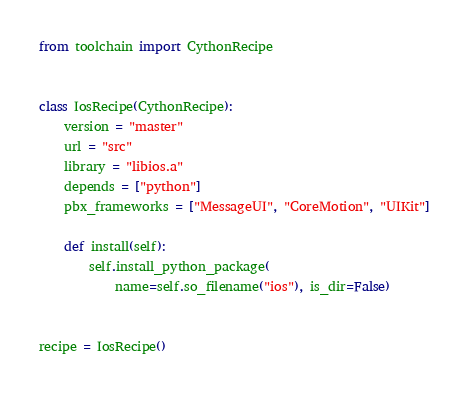<code> <loc_0><loc_0><loc_500><loc_500><_Python_>from toolchain import CythonRecipe


class IosRecipe(CythonRecipe):
    version = "master"
    url = "src"
    library = "libios.a"
    depends = ["python"]
    pbx_frameworks = ["MessageUI", "CoreMotion", "UIKit"]

    def install(self):
        self.install_python_package(
            name=self.so_filename("ios"), is_dir=False)


recipe = IosRecipe()
</code> 